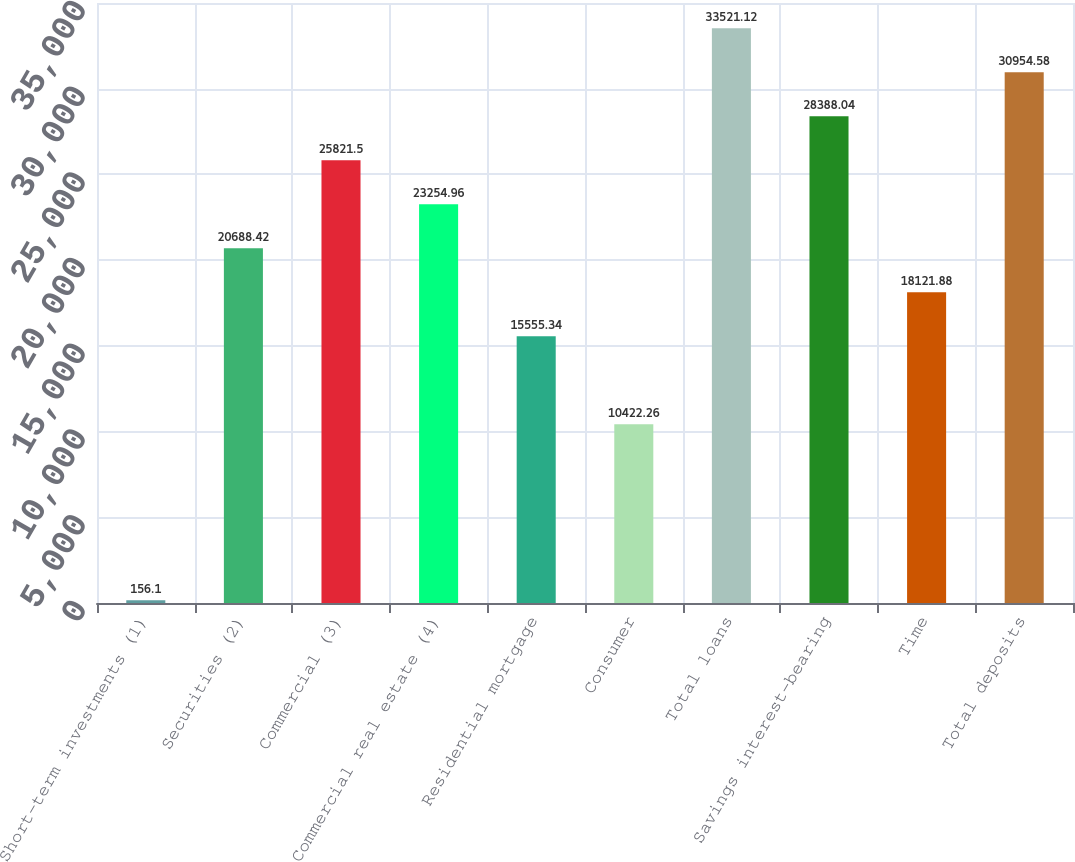<chart> <loc_0><loc_0><loc_500><loc_500><bar_chart><fcel>Short-term investments (1)<fcel>Securities (2)<fcel>Commercial (3)<fcel>Commercial real estate (4)<fcel>Residential mortgage<fcel>Consumer<fcel>Total loans<fcel>Savings interest-bearing<fcel>Time<fcel>Total deposits<nl><fcel>156.1<fcel>20688.4<fcel>25821.5<fcel>23255<fcel>15555.3<fcel>10422.3<fcel>33521.1<fcel>28388<fcel>18121.9<fcel>30954.6<nl></chart> 